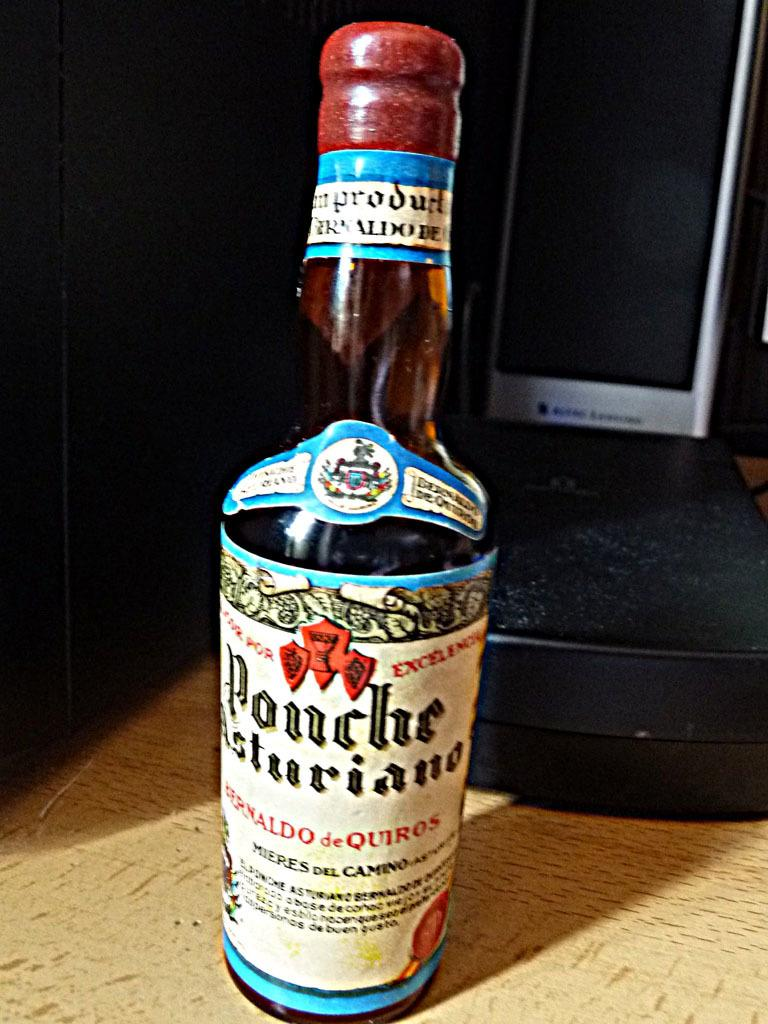<image>
Write a terse but informative summary of the picture. Tall bottle with a label that says "PONCHE" on it. 